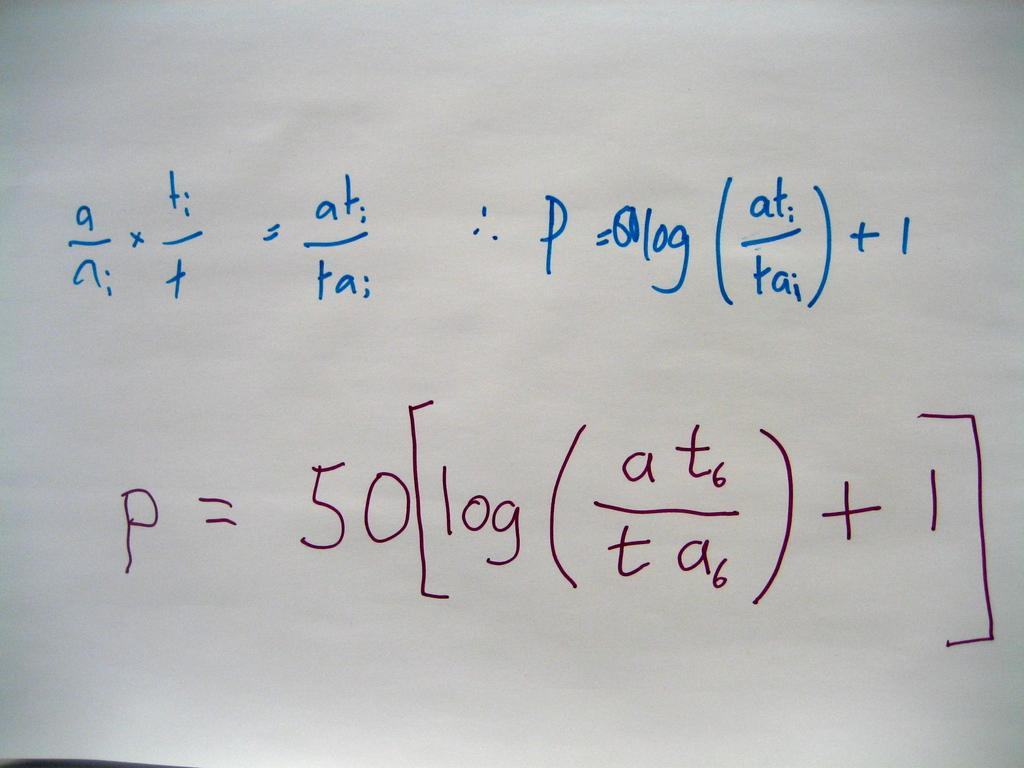<image>
Provide a brief description of the given image. A white board with the letter p written on it. 